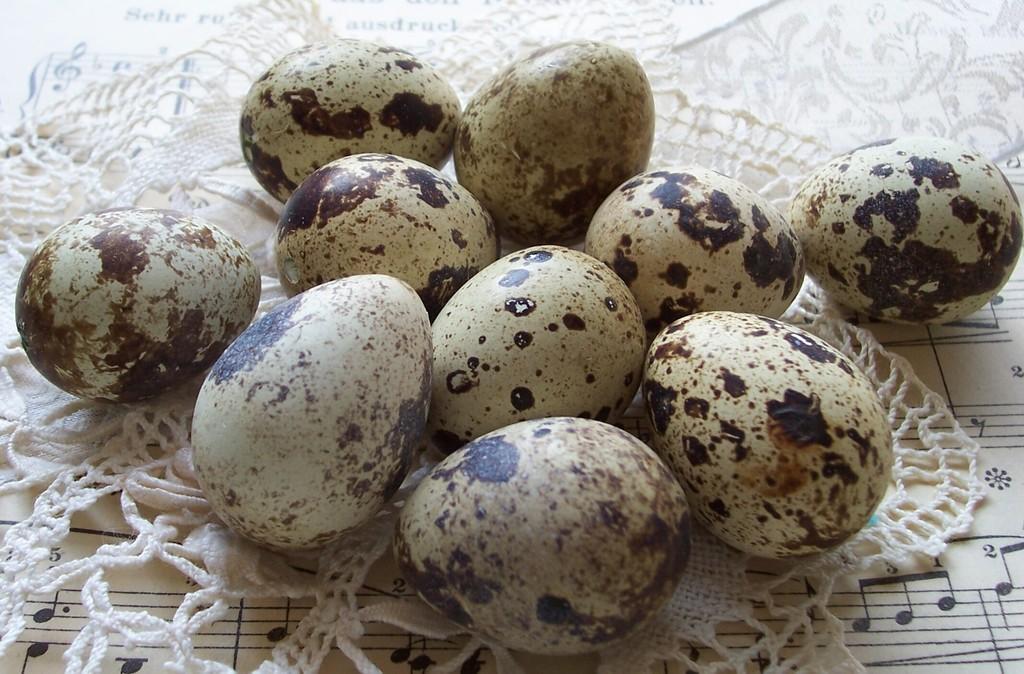Can you describe this image briefly? In this picture I can see number of eggs on a cloth and under the cloth I see a paper on which there are musical notes written. 